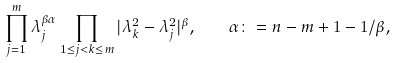<formula> <loc_0><loc_0><loc_500><loc_500>\prod _ { j = 1 } ^ { m } \lambda _ { j } ^ { \beta \alpha } \prod _ { 1 \leq j < k \leq m } | \lambda _ { k } ^ { 2 } - \lambda _ { j } ^ { 2 } | ^ { \beta } , \quad \alpha \colon = n - m + 1 - 1 / \beta ,</formula> 